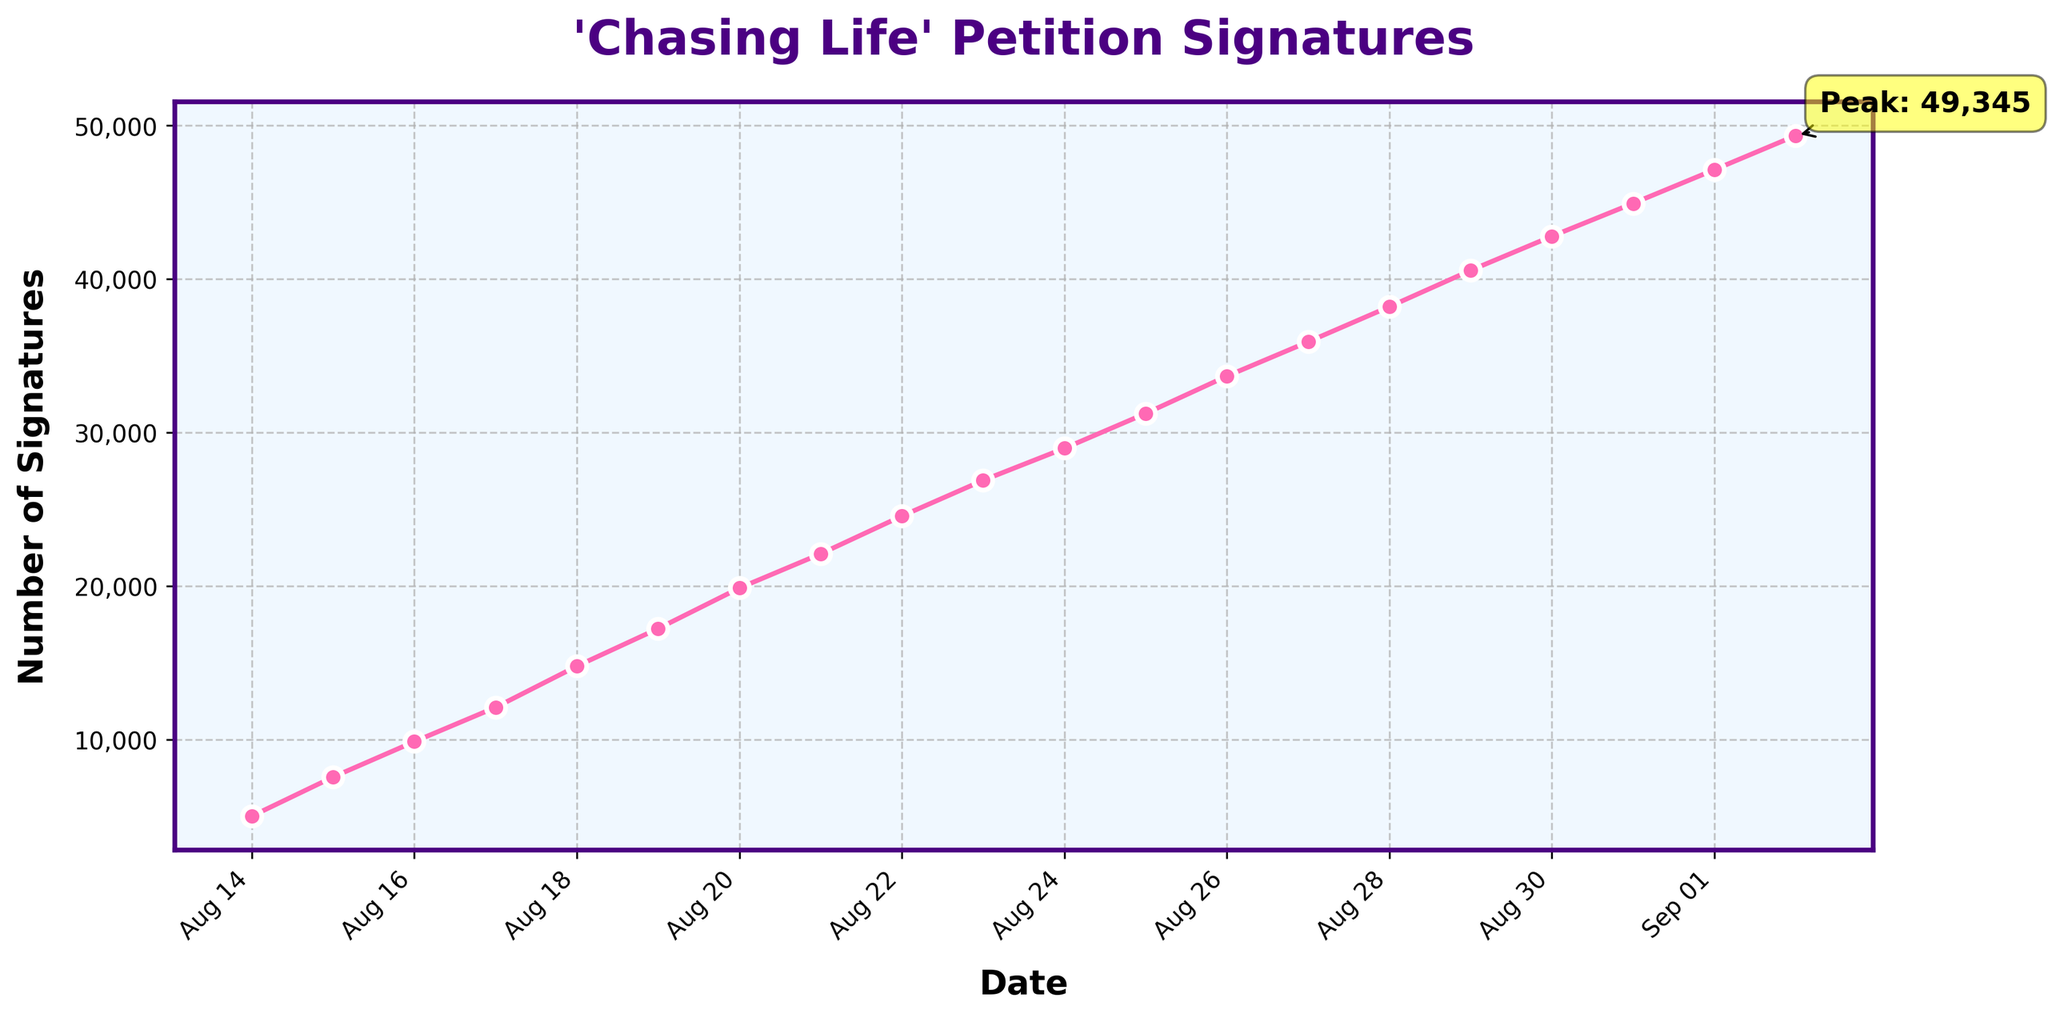How many signatures were there on August 17th and how many more were there by August 19th? On August 17th, the number of signatures was 12,105. On August 19th, the number of signatures was 17,234. To find how many more signatures there were, we subtract 12,105 from 17,234, which equals 5,129.
Answer: 5,129 By how much did the number of signatures increase between August 14th and August 25th? On August 14th, there were 5,023 signatures. On August 25th, there were 31,245 signatures. The increase is calculated by subtracting 5,023 from 31,245, resulting in 26,222.
Answer: 26,222 Which date shows the peak number of signatures and what is this value? The peak number of signatures is highlighted with an annotation. The date at this peak is September 2nd, with 49,345 signatures.
Answer: September 2nd, 49,345 By which date did the petition gather more than 20,000 signatures? The figure shows the number of signatures crossing the 20,000 mark between August 20th and August 21st. Therefore, the petition gathered more than 20,000 signatures by August 21st.
Answer: August 21st How many signatures were added between August 28th and August 30th? On August 28th, there were 38,201 signatures. On August 30th, there were 42,789 signatures. The number of signatures added between these two dates is calculated by subtracting 38,201 from 42,789, which equals 4,588.
Answer: 4,588 On which date was there a more significant increase in signatures: August 16th or August 17th? The increase in signatures from August 15th to August 16th is 2,304 (9,872 - 7,568). The increase from August 16th to August 17th is 2,233 (12,105 - 9,872). Comparing these, the increase on August 16th is larger by 71 signatures.
Answer: August 16th Between which consecutive dates was the largest single-day increase in signatures observed? We need to identify the largest daily increase by comparing each consecutive day. The largest increase is between August 28th and August 29th, where signatures rose from 38,201 to 40,567, a change of 2,366 signatures.
Answer: August 28th to August 29th On average, how many signatures were added daily between August 14th and September 2nd? To find the daily average increase, we calculate the total increase over the period from August 14th (5,023 signatures) to September 2nd (49,345 signatures), which is 49,345 - 5,023 = 44,322. The period includes 19 days (from 14th to 2nd inclusive). So, the average daily increase is 44,322 / 19 ≈ 2,332.
Answer: ~2,332 What is the color of the line used in the plot? The color of the line as described is pink.
Answer: Pink Which date marks the first point where the number of signatures exceeds 10,000? Observing the chart, the first date where the number of signatures exceeds 10,000 is August 16th.
Answer: August 16th 